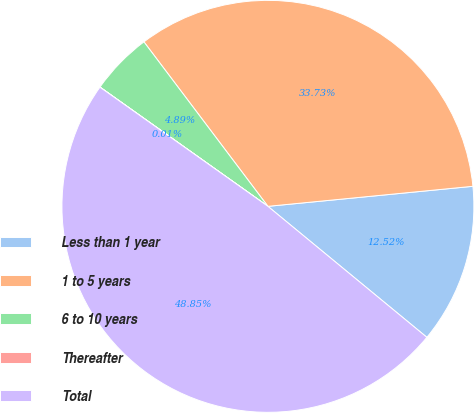Convert chart to OTSL. <chart><loc_0><loc_0><loc_500><loc_500><pie_chart><fcel>Less than 1 year<fcel>1 to 5 years<fcel>6 to 10 years<fcel>Thereafter<fcel>Total<nl><fcel>12.52%<fcel>33.73%<fcel>4.89%<fcel>0.01%<fcel>48.85%<nl></chart> 